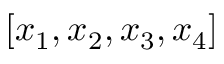Convert formula to latex. <formula><loc_0><loc_0><loc_500><loc_500>[ x _ { 1 } , x _ { 2 } , x _ { 3 } , x _ { 4 } ]</formula> 